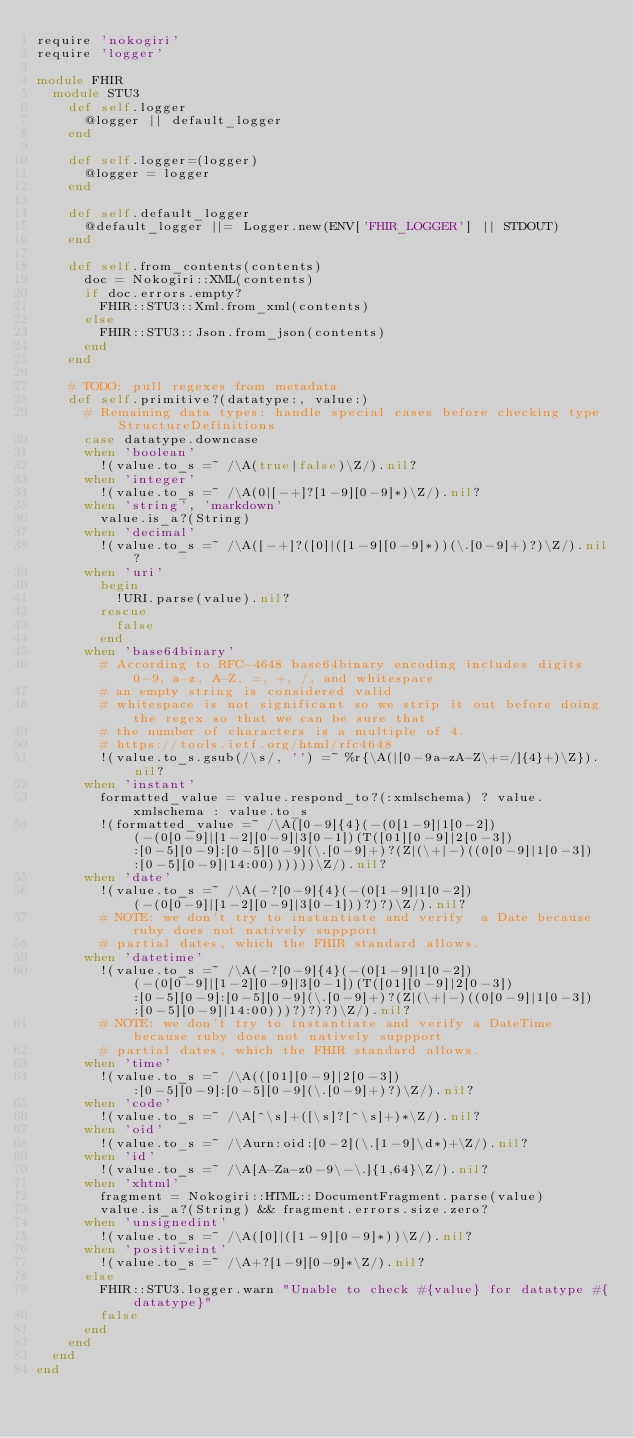<code> <loc_0><loc_0><loc_500><loc_500><_Ruby_>require 'nokogiri'
require 'logger'

module FHIR
  module STU3
    def self.logger
      @logger || default_logger
    end

    def self.logger=(logger)
      @logger = logger
    end

    def self.default_logger
      @default_logger ||= Logger.new(ENV['FHIR_LOGGER'] || STDOUT)
    end

    def self.from_contents(contents)
      doc = Nokogiri::XML(contents)
      if doc.errors.empty?
        FHIR::STU3::Xml.from_xml(contents)
      else
        FHIR::STU3::Json.from_json(contents)
      end
    end

    # TODO: pull regexes from metadata
    def self.primitive?(datatype:, value:)
      # Remaining data types: handle special cases before checking type StructureDefinitions
      case datatype.downcase
      when 'boolean'
        !(value.to_s =~ /\A(true|false)\Z/).nil?
      when 'integer'
        !(value.to_s =~ /\A(0|[-+]?[1-9][0-9]*)\Z/).nil?
      when 'string', 'markdown'
        value.is_a?(String)
      when 'decimal'
        !(value.to_s =~ /\A([-+]?([0]|([1-9][0-9]*))(\.[0-9]+)?)\Z/).nil?
      when 'uri'
        begin
          !URI.parse(value).nil?
        rescue
          false
        end
      when 'base64binary'
        # According to RFC-4648 base64binary encoding includes digits 0-9, a-z, A-Z, =, +, /, and whitespace
        # an empty string is considered valid
        # whitespace is not significant so we strip it out before doing the regex so that we can be sure that
        # the number of characters is a multiple of 4.
        # https://tools.ietf.org/html/rfc4648
        !(value.to_s.gsub(/\s/, '') =~ %r{\A(|[0-9a-zA-Z\+=/]{4}+)\Z}).nil?
      when 'instant'
        formatted_value = value.respond_to?(:xmlschema) ? value.xmlschema : value.to_s
        !(formatted_value =~ /\A([0-9]{4}(-(0[1-9]|1[0-2])(-(0[0-9]|[1-2][0-9]|3[0-1])(T([01][0-9]|2[0-3]):[0-5][0-9]:[0-5][0-9](\.[0-9]+)?(Z|(\+|-)((0[0-9]|1[0-3]):[0-5][0-9]|14:00))))))\Z/).nil?
      when 'date'
        !(value.to_s =~ /\A(-?[0-9]{4}(-(0[1-9]|1[0-2])(-(0[0-9]|[1-2][0-9]|3[0-1]))?)?)\Z/).nil?
        # NOTE: we don't try to instantiate and verify  a Date because ruby does not natively suppport
        # partial dates, which the FHIR standard allows.
      when 'datetime'
        !(value.to_s =~ /\A(-?[0-9]{4}(-(0[1-9]|1[0-2])(-(0[0-9]|[1-2][0-9]|3[0-1])(T([01][0-9]|2[0-3]):[0-5][0-9]:[0-5][0-9](\.[0-9]+)?(Z|(\+|-)((0[0-9]|1[0-3]):[0-5][0-9]|14:00)))?)?)?)\Z/).nil?
        # NOTE: we don't try to instantiate and verify a DateTime because ruby does not natively suppport
        # partial dates, which the FHIR standard allows.
      when 'time'
        !(value.to_s =~ /\A(([01][0-9]|2[0-3]):[0-5][0-9]:[0-5][0-9](\.[0-9]+)?)\Z/).nil?
      when 'code'
        !(value.to_s =~ /\A[^\s]+([\s]?[^\s]+)*\Z/).nil?
      when 'oid'
        !(value.to_s =~ /\Aurn:oid:[0-2](\.[1-9]\d*)+\Z/).nil?
      when 'id'
        !(value.to_s =~ /\A[A-Za-z0-9\-\.]{1,64}\Z/).nil?
      when 'xhtml'
        fragment = Nokogiri::HTML::DocumentFragment.parse(value)
        value.is_a?(String) && fragment.errors.size.zero?
      when 'unsignedint'
        !(value.to_s =~ /\A([0]|([1-9][0-9]*))\Z/).nil?
      when 'positiveint'
        !(value.to_s =~ /\A+?[1-9][0-9]*\Z/).nil?
      else
        FHIR::STU3.logger.warn "Unable to check #{value} for datatype #{datatype}"
        false
      end
    end
  end
end
</code> 